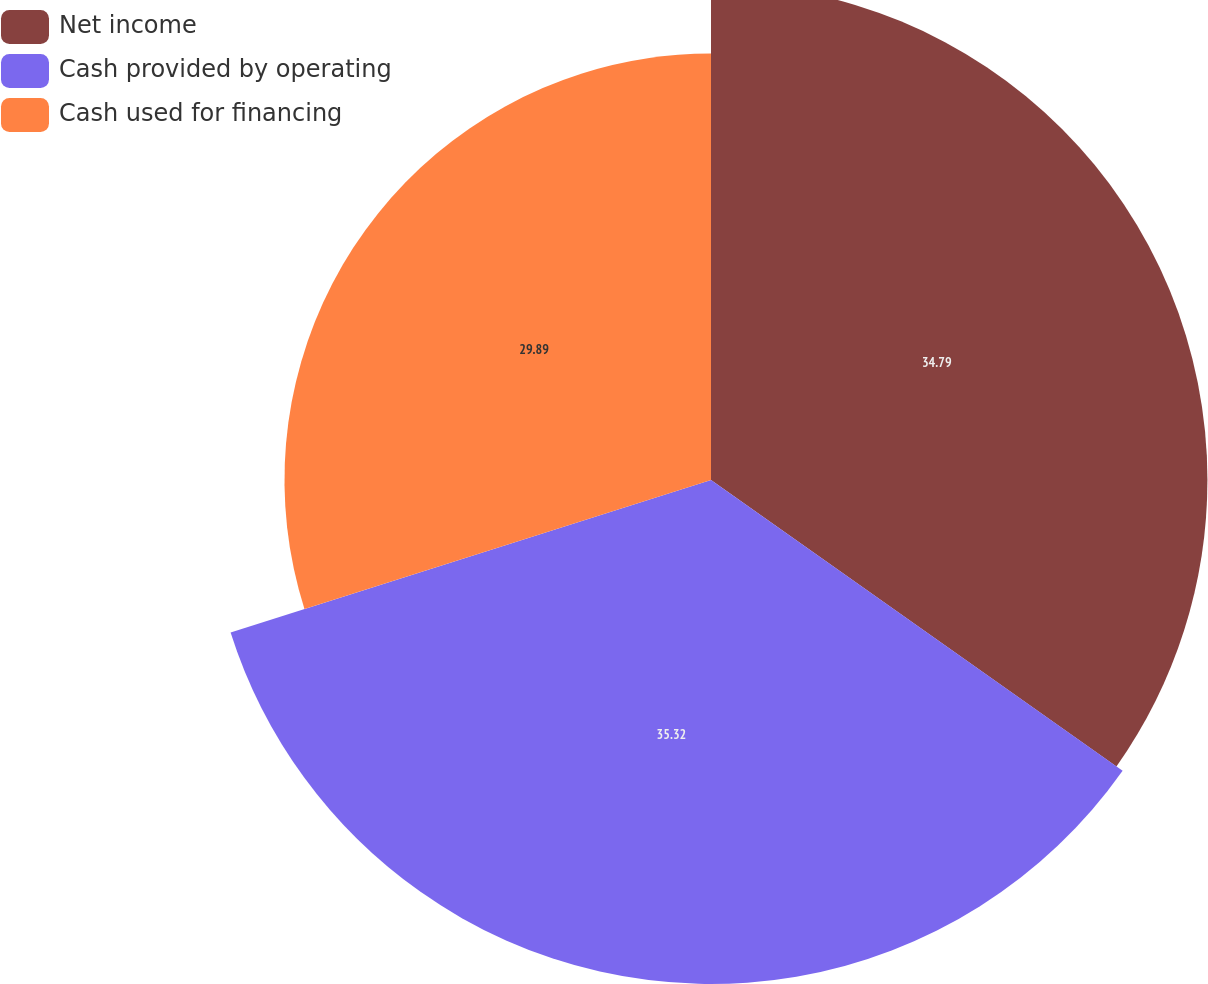<chart> <loc_0><loc_0><loc_500><loc_500><pie_chart><fcel>Net income<fcel>Cash provided by operating<fcel>Cash used for financing<nl><fcel>34.79%<fcel>35.32%<fcel>29.89%<nl></chart> 